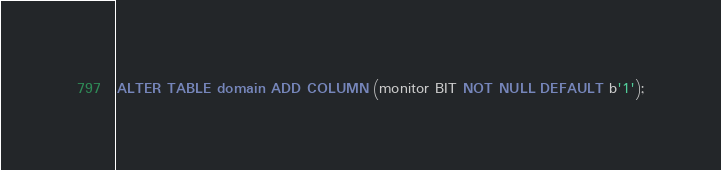<code> <loc_0><loc_0><loc_500><loc_500><_SQL_>ALTER TABLE domain ADD COLUMN (monitor BIT NOT NULL DEFAULT b'1');



</code> 